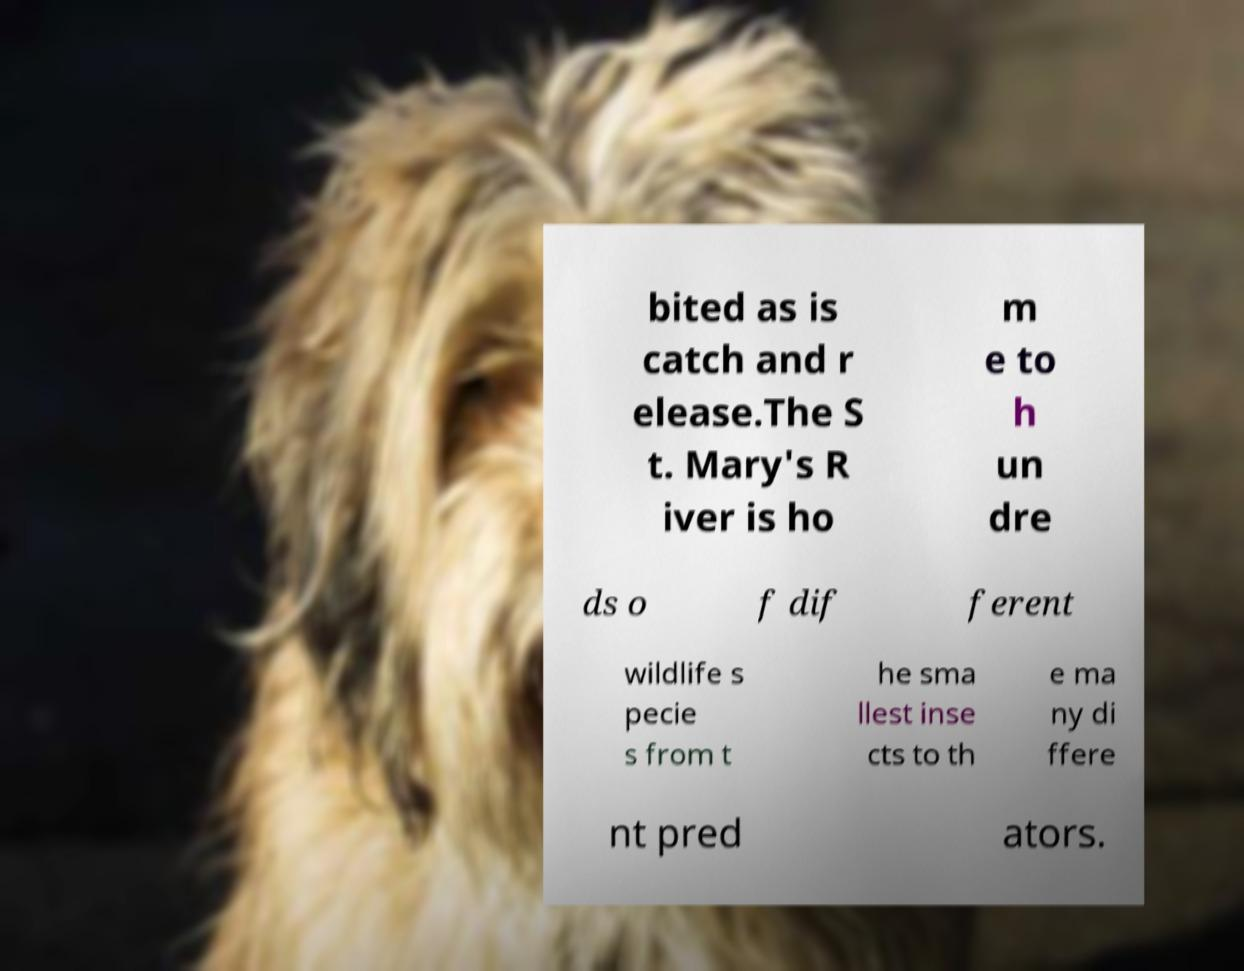Please identify and transcribe the text found in this image. bited as is catch and r elease.The S t. Mary's R iver is ho m e to h un dre ds o f dif ferent wildlife s pecie s from t he sma llest inse cts to th e ma ny di ffere nt pred ators. 